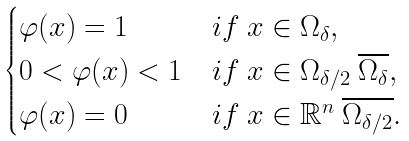<formula> <loc_0><loc_0><loc_500><loc_500>\begin{cases} \varphi ( x ) = 1 & i f \ x \in \Omega _ { \delta } , \\ 0 < \varphi ( x ) < 1 & i f \ x \in \Omega _ { \delta / 2 } \ \overline { \Omega _ { \delta } } , \\ \varphi ( x ) = 0 & i f \ x \in \mathbb { R } ^ { n } \ \overline { \Omega _ { \delta / 2 } } . \end{cases}</formula> 